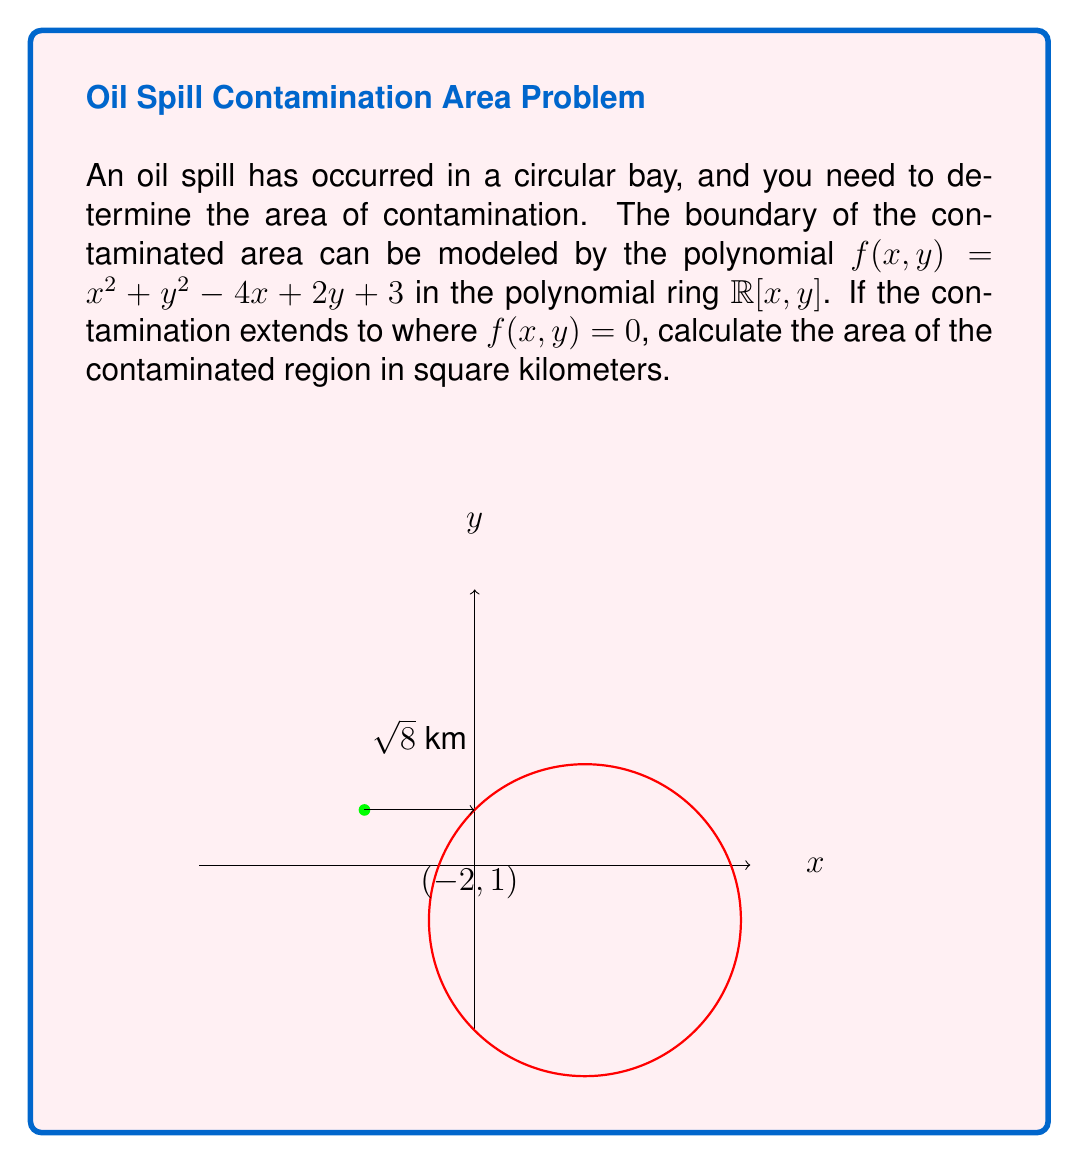Give your solution to this math problem. Let's approach this step-by-step:

1) The polynomial $f(x,y) = x^2 + y^2 - 4x + 2y + 3$ represents a circle in the $xy$-plane.

2) To find the center and radius of this circle, we need to rewrite it in standard form $(x-h)^2 + (y-k)^2 = r^2$, where $(h,k)$ is the center and $r$ is the radius.

3) Rearranging the terms:
   $$(x^2 - 4x) + (y^2 + 2y) = -3$$
   $$(x^2 - 4x + 4) + (y^2 + 2y + 1) = -3 + 4 + 1$$
   $$(x - 2)^2 + (y + 1)^2 = 2$$

4) From this, we can see that the center is at $(2,-1)$, or more precisely $(-2,1)$ in our coordinate system.

5) The radius $r$ satisfies $r^2 = 2$, so $r = \sqrt{2}$ km.

6) The area of a circle is given by the formula $A = \pi r^2$.

7) Substituting our radius:
   $$A = \pi (\sqrt{2})^2 = 2\pi$$ km²

Therefore, the area of contamination is $2\pi$ square kilometers.
Answer: $2\pi$ km² 